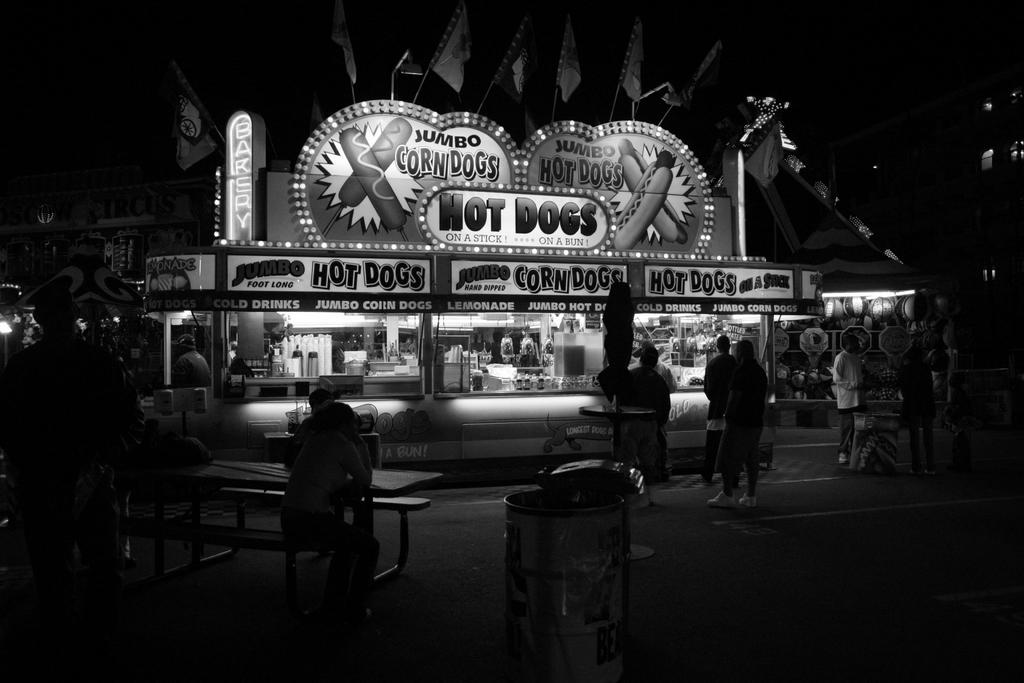Provide a one-sentence caption for the provided image. A photograph shows an old Hot Dog stand. 